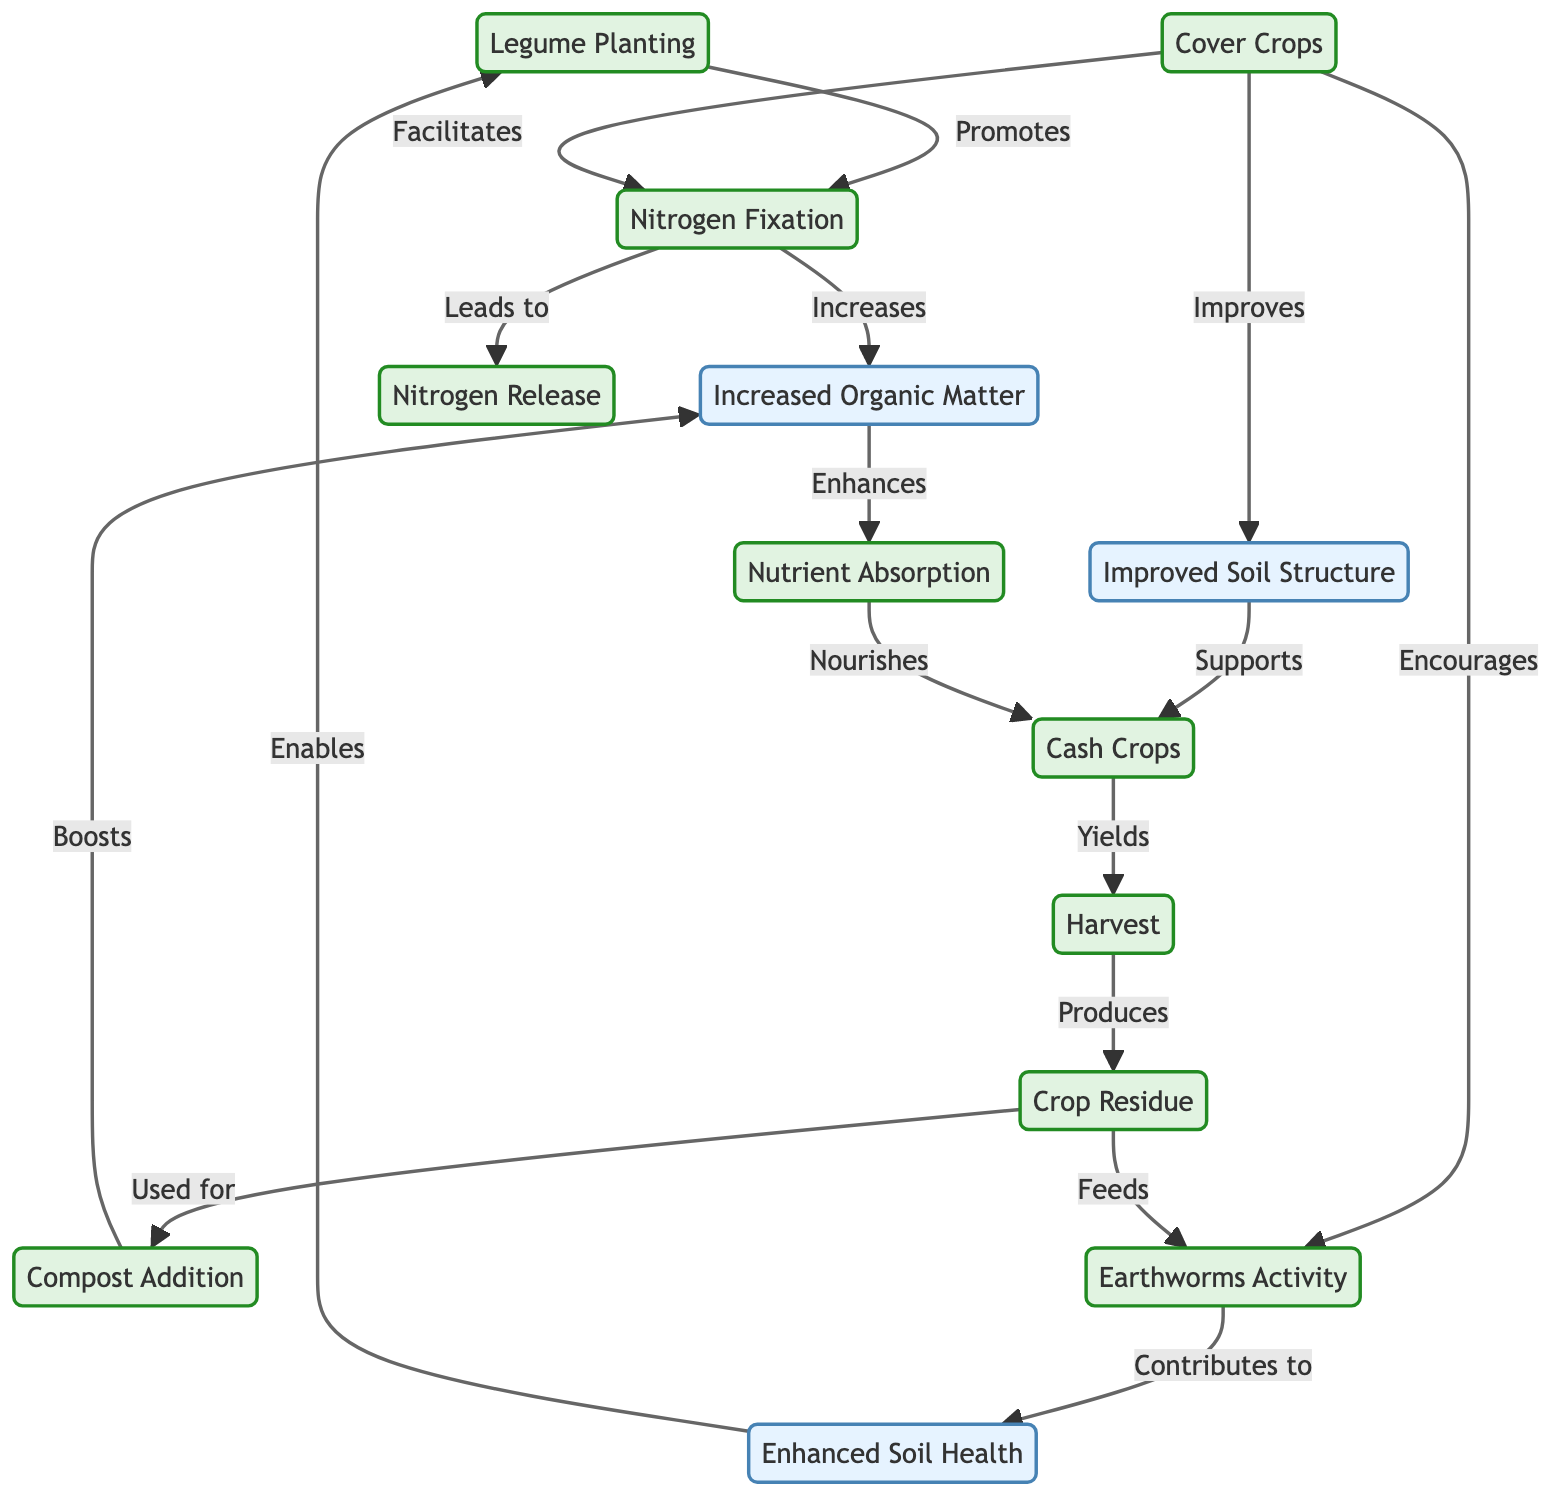What is the first step in the soil nutrient replenishment cycle? The first step in the cycle is "Legume Planting" as it is the starting node in the diagram.
Answer: Legume Planting How many nodes are present in the diagram? The diagram lists a total of 13 distinct nodes representing different elements of the soil nutrient replenishment cycle.
Answer: 13 What does "Nitrogen Fixation" lead to? "Nitrogen Fixation" leads to "Nitrogen Release" as indicated by the directed edge in the diagram that connects these two nodes.
Answer: Nitrogen Release Which process improves soil structure according to the diagram? The process that improves soil structure is "Cover Crops," as shown by the directed edge leading to "Improved Soil Structure."
Answer: Cover Crops What is the relationship between "Crop Residue" and "Compost Addition"? The relationship is that "Crop Residue" is used for "Compost Addition," reflecting the action indicated in the diagram with a direct arrow between the two nodes.
Answer: Used for Which activity does "Earthworms Activity" contribute to? "Earthworms Activity" contributes to "Soil Health," as shown by the directed edge in the diagram connecting these two nodes.
Answer: Soil Health How many edges connect "Legume Planting" to other nodes? "Legume Planting" connects to one other node, which is "Nitrogen Fixation," based on the direct edge in the diagram.
Answer: 1 What are the final results after "Cash Crops"? The final results after "Cash Crops" is "Harvest," indicating the yield from the cash crops as represented by the directed edge.
Answer: Harvest Which node feeds into "Earthworms Activity"? "Crop Residue" feeds into "Earthworms Activity," as indicated by the diagram, which shows a directed edge pointing from "Crop Residue" to "Earthworms Activity."
Answer: Crop Residue 